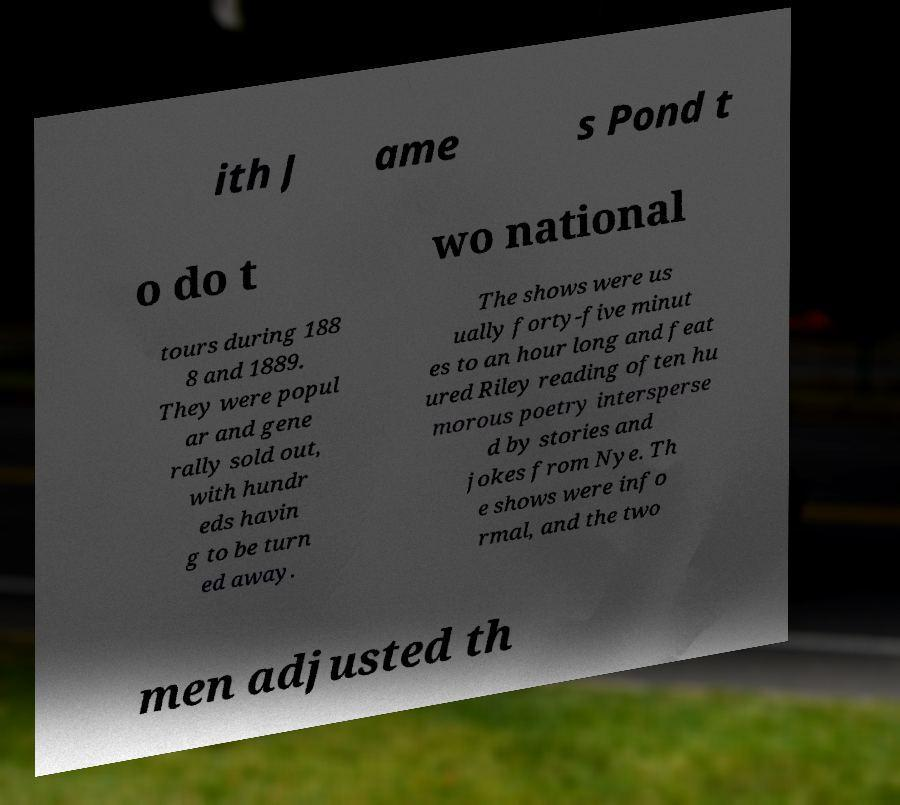I need the written content from this picture converted into text. Can you do that? ith J ame s Pond t o do t wo national tours during 188 8 and 1889. They were popul ar and gene rally sold out, with hundr eds havin g to be turn ed away. The shows were us ually forty-five minut es to an hour long and feat ured Riley reading often hu morous poetry intersperse d by stories and jokes from Nye. Th e shows were info rmal, and the two men adjusted th 